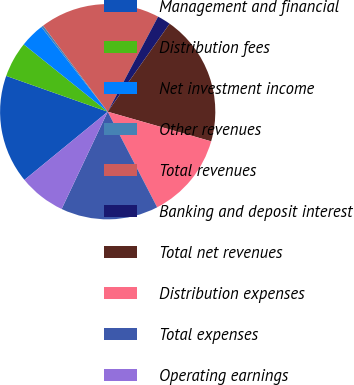Convert chart. <chart><loc_0><loc_0><loc_500><loc_500><pie_chart><fcel>Management and financial<fcel>Distribution fees<fcel>Net investment income<fcel>Other revenues<fcel>Total revenues<fcel>Banking and deposit interest<fcel>Total net revenues<fcel>Distribution expenses<fcel>Total expenses<fcel>Operating earnings<nl><fcel>16.32%<fcel>5.36%<fcel>3.68%<fcel>0.32%<fcel>18.0%<fcel>2.0%<fcel>19.68%<fcel>12.96%<fcel>14.64%<fcel>7.04%<nl></chart> 